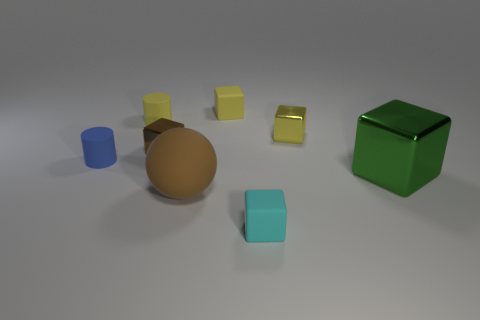Subtract all brown blocks. How many blocks are left? 4 Subtract all big cubes. How many cubes are left? 4 Subtract all purple cylinders. Subtract all blue cubes. How many cylinders are left? 2 Add 1 small gray rubber cylinders. How many objects exist? 9 Subtract all cylinders. How many objects are left? 6 Subtract all tiny yellow matte objects. Subtract all small things. How many objects are left? 0 Add 4 tiny yellow matte cubes. How many tiny yellow matte cubes are left? 5 Add 5 cyan matte cubes. How many cyan matte cubes exist? 6 Subtract 1 blue cylinders. How many objects are left? 7 